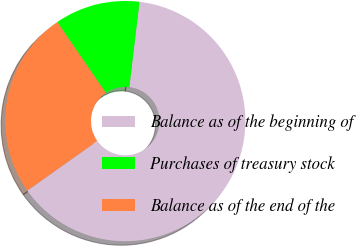<chart> <loc_0><loc_0><loc_500><loc_500><pie_chart><fcel>Balance as of the beginning of<fcel>Purchases of treasury stock<fcel>Balance as of the end of the<nl><fcel>63.29%<fcel>11.47%<fcel>25.24%<nl></chart> 